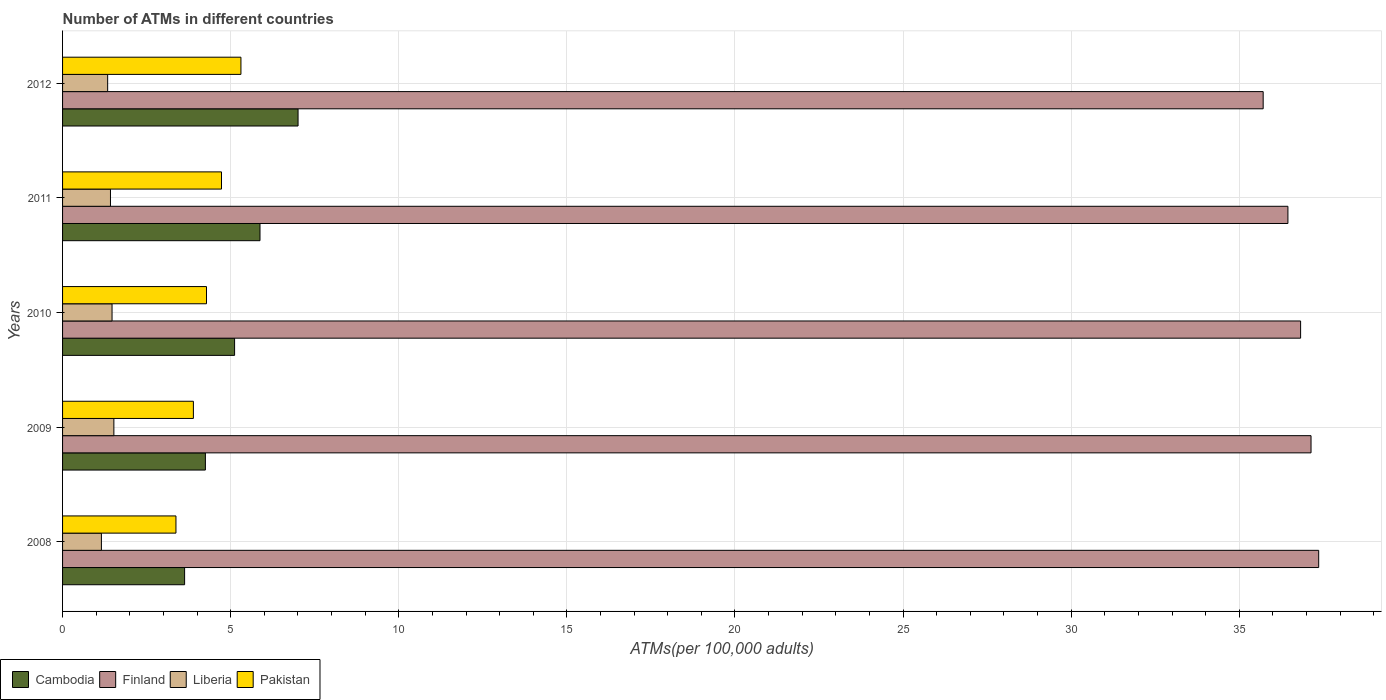Are the number of bars per tick equal to the number of legend labels?
Provide a short and direct response. Yes. How many bars are there on the 3rd tick from the bottom?
Your answer should be very brief. 4. In how many cases, is the number of bars for a given year not equal to the number of legend labels?
Your response must be concise. 0. What is the number of ATMs in Cambodia in 2008?
Your answer should be compact. 3.63. Across all years, what is the maximum number of ATMs in Liberia?
Ensure brevity in your answer.  1.53. Across all years, what is the minimum number of ATMs in Pakistan?
Make the answer very short. 3.37. In which year was the number of ATMs in Finland maximum?
Provide a short and direct response. 2008. In which year was the number of ATMs in Finland minimum?
Give a very brief answer. 2012. What is the total number of ATMs in Finland in the graph?
Your response must be concise. 183.48. What is the difference between the number of ATMs in Pakistan in 2011 and that in 2012?
Provide a short and direct response. -0.58. What is the difference between the number of ATMs in Liberia in 2010 and the number of ATMs in Cambodia in 2008?
Your answer should be very brief. -2.16. What is the average number of ATMs in Cambodia per year?
Provide a succinct answer. 5.17. In the year 2010, what is the difference between the number of ATMs in Liberia and number of ATMs in Finland?
Offer a very short reply. -35.35. What is the ratio of the number of ATMs in Pakistan in 2009 to that in 2011?
Offer a very short reply. 0.82. Is the number of ATMs in Liberia in 2008 less than that in 2009?
Ensure brevity in your answer.  Yes. What is the difference between the highest and the second highest number of ATMs in Finland?
Your answer should be compact. 0.23. What is the difference between the highest and the lowest number of ATMs in Liberia?
Provide a short and direct response. 0.37. In how many years, is the number of ATMs in Cambodia greater than the average number of ATMs in Cambodia taken over all years?
Offer a very short reply. 2. Is the sum of the number of ATMs in Pakistan in 2010 and 2011 greater than the maximum number of ATMs in Cambodia across all years?
Make the answer very short. Yes. What does the 4th bar from the top in 2011 represents?
Keep it short and to the point. Cambodia. Is it the case that in every year, the sum of the number of ATMs in Pakistan and number of ATMs in Liberia is greater than the number of ATMs in Finland?
Provide a short and direct response. No. How many bars are there?
Your answer should be compact. 20. Are all the bars in the graph horizontal?
Provide a short and direct response. Yes. How many years are there in the graph?
Give a very brief answer. 5. What is the difference between two consecutive major ticks on the X-axis?
Your response must be concise. 5. Are the values on the major ticks of X-axis written in scientific E-notation?
Keep it short and to the point. No. Does the graph contain any zero values?
Make the answer very short. No. How are the legend labels stacked?
Offer a very short reply. Horizontal. What is the title of the graph?
Provide a succinct answer. Number of ATMs in different countries. What is the label or title of the X-axis?
Your answer should be compact. ATMs(per 100,0 adults). What is the label or title of the Y-axis?
Offer a terse response. Years. What is the ATMs(per 100,000 adults) of Cambodia in 2008?
Provide a succinct answer. 3.63. What is the ATMs(per 100,000 adults) of Finland in 2008?
Your answer should be very brief. 37.36. What is the ATMs(per 100,000 adults) of Liberia in 2008?
Offer a very short reply. 1.16. What is the ATMs(per 100,000 adults) in Pakistan in 2008?
Offer a terse response. 3.37. What is the ATMs(per 100,000 adults) of Cambodia in 2009?
Your answer should be very brief. 4.25. What is the ATMs(per 100,000 adults) of Finland in 2009?
Keep it short and to the point. 37.13. What is the ATMs(per 100,000 adults) in Liberia in 2009?
Make the answer very short. 1.53. What is the ATMs(per 100,000 adults) in Pakistan in 2009?
Keep it short and to the point. 3.89. What is the ATMs(per 100,000 adults) of Cambodia in 2010?
Give a very brief answer. 5.12. What is the ATMs(per 100,000 adults) in Finland in 2010?
Offer a terse response. 36.82. What is the ATMs(per 100,000 adults) in Liberia in 2010?
Ensure brevity in your answer.  1.47. What is the ATMs(per 100,000 adults) in Pakistan in 2010?
Keep it short and to the point. 4.28. What is the ATMs(per 100,000 adults) in Cambodia in 2011?
Offer a very short reply. 5.87. What is the ATMs(per 100,000 adults) in Finland in 2011?
Provide a succinct answer. 36.45. What is the ATMs(per 100,000 adults) in Liberia in 2011?
Offer a terse response. 1.42. What is the ATMs(per 100,000 adults) of Pakistan in 2011?
Make the answer very short. 4.73. What is the ATMs(per 100,000 adults) of Cambodia in 2012?
Give a very brief answer. 7. What is the ATMs(per 100,000 adults) of Finland in 2012?
Your answer should be very brief. 35.71. What is the ATMs(per 100,000 adults) in Liberia in 2012?
Keep it short and to the point. 1.34. What is the ATMs(per 100,000 adults) of Pakistan in 2012?
Your answer should be compact. 5.31. Across all years, what is the maximum ATMs(per 100,000 adults) of Cambodia?
Offer a very short reply. 7. Across all years, what is the maximum ATMs(per 100,000 adults) in Finland?
Provide a short and direct response. 37.36. Across all years, what is the maximum ATMs(per 100,000 adults) of Liberia?
Offer a terse response. 1.53. Across all years, what is the maximum ATMs(per 100,000 adults) in Pakistan?
Make the answer very short. 5.31. Across all years, what is the minimum ATMs(per 100,000 adults) in Cambodia?
Offer a terse response. 3.63. Across all years, what is the minimum ATMs(per 100,000 adults) in Finland?
Your response must be concise. 35.71. Across all years, what is the minimum ATMs(per 100,000 adults) in Liberia?
Your answer should be very brief. 1.16. Across all years, what is the minimum ATMs(per 100,000 adults) in Pakistan?
Provide a succinct answer. 3.37. What is the total ATMs(per 100,000 adults) in Cambodia in the graph?
Your response must be concise. 25.87. What is the total ATMs(per 100,000 adults) of Finland in the graph?
Offer a terse response. 183.48. What is the total ATMs(per 100,000 adults) of Liberia in the graph?
Your response must be concise. 6.92. What is the total ATMs(per 100,000 adults) of Pakistan in the graph?
Provide a succinct answer. 21.58. What is the difference between the ATMs(per 100,000 adults) of Cambodia in 2008 and that in 2009?
Offer a terse response. -0.62. What is the difference between the ATMs(per 100,000 adults) of Finland in 2008 and that in 2009?
Make the answer very short. 0.23. What is the difference between the ATMs(per 100,000 adults) of Liberia in 2008 and that in 2009?
Your response must be concise. -0.37. What is the difference between the ATMs(per 100,000 adults) in Pakistan in 2008 and that in 2009?
Your response must be concise. -0.52. What is the difference between the ATMs(per 100,000 adults) in Cambodia in 2008 and that in 2010?
Your answer should be compact. -1.49. What is the difference between the ATMs(per 100,000 adults) of Finland in 2008 and that in 2010?
Your answer should be very brief. 0.54. What is the difference between the ATMs(per 100,000 adults) in Liberia in 2008 and that in 2010?
Offer a terse response. -0.32. What is the difference between the ATMs(per 100,000 adults) in Pakistan in 2008 and that in 2010?
Provide a succinct answer. -0.91. What is the difference between the ATMs(per 100,000 adults) of Cambodia in 2008 and that in 2011?
Your answer should be very brief. -2.24. What is the difference between the ATMs(per 100,000 adults) of Finland in 2008 and that in 2011?
Offer a very short reply. 0.92. What is the difference between the ATMs(per 100,000 adults) of Liberia in 2008 and that in 2011?
Ensure brevity in your answer.  -0.27. What is the difference between the ATMs(per 100,000 adults) in Pakistan in 2008 and that in 2011?
Your answer should be very brief. -1.35. What is the difference between the ATMs(per 100,000 adults) of Cambodia in 2008 and that in 2012?
Provide a succinct answer. -3.37. What is the difference between the ATMs(per 100,000 adults) in Finland in 2008 and that in 2012?
Your answer should be very brief. 1.65. What is the difference between the ATMs(per 100,000 adults) in Liberia in 2008 and that in 2012?
Make the answer very short. -0.19. What is the difference between the ATMs(per 100,000 adults) of Pakistan in 2008 and that in 2012?
Offer a terse response. -1.93. What is the difference between the ATMs(per 100,000 adults) in Cambodia in 2009 and that in 2010?
Offer a very short reply. -0.87. What is the difference between the ATMs(per 100,000 adults) in Finland in 2009 and that in 2010?
Keep it short and to the point. 0.31. What is the difference between the ATMs(per 100,000 adults) of Liberia in 2009 and that in 2010?
Make the answer very short. 0.05. What is the difference between the ATMs(per 100,000 adults) of Pakistan in 2009 and that in 2010?
Keep it short and to the point. -0.39. What is the difference between the ATMs(per 100,000 adults) of Cambodia in 2009 and that in 2011?
Provide a succinct answer. -1.62. What is the difference between the ATMs(per 100,000 adults) in Finland in 2009 and that in 2011?
Give a very brief answer. 0.69. What is the difference between the ATMs(per 100,000 adults) in Liberia in 2009 and that in 2011?
Offer a terse response. 0.1. What is the difference between the ATMs(per 100,000 adults) of Pakistan in 2009 and that in 2011?
Keep it short and to the point. -0.84. What is the difference between the ATMs(per 100,000 adults) of Cambodia in 2009 and that in 2012?
Provide a succinct answer. -2.76. What is the difference between the ATMs(per 100,000 adults) of Finland in 2009 and that in 2012?
Your answer should be compact. 1.42. What is the difference between the ATMs(per 100,000 adults) of Liberia in 2009 and that in 2012?
Your answer should be very brief. 0.19. What is the difference between the ATMs(per 100,000 adults) of Pakistan in 2009 and that in 2012?
Offer a very short reply. -1.41. What is the difference between the ATMs(per 100,000 adults) in Cambodia in 2010 and that in 2011?
Keep it short and to the point. -0.76. What is the difference between the ATMs(per 100,000 adults) in Finland in 2010 and that in 2011?
Make the answer very short. 0.38. What is the difference between the ATMs(per 100,000 adults) of Liberia in 2010 and that in 2011?
Ensure brevity in your answer.  0.05. What is the difference between the ATMs(per 100,000 adults) of Pakistan in 2010 and that in 2011?
Keep it short and to the point. -0.45. What is the difference between the ATMs(per 100,000 adults) of Cambodia in 2010 and that in 2012?
Offer a terse response. -1.89. What is the difference between the ATMs(per 100,000 adults) of Finland in 2010 and that in 2012?
Give a very brief answer. 1.11. What is the difference between the ATMs(per 100,000 adults) of Liberia in 2010 and that in 2012?
Offer a terse response. 0.13. What is the difference between the ATMs(per 100,000 adults) of Pakistan in 2010 and that in 2012?
Make the answer very short. -1.02. What is the difference between the ATMs(per 100,000 adults) of Cambodia in 2011 and that in 2012?
Provide a short and direct response. -1.13. What is the difference between the ATMs(per 100,000 adults) of Finland in 2011 and that in 2012?
Make the answer very short. 0.74. What is the difference between the ATMs(per 100,000 adults) of Liberia in 2011 and that in 2012?
Keep it short and to the point. 0.08. What is the difference between the ATMs(per 100,000 adults) in Pakistan in 2011 and that in 2012?
Provide a short and direct response. -0.58. What is the difference between the ATMs(per 100,000 adults) in Cambodia in 2008 and the ATMs(per 100,000 adults) in Finland in 2009?
Your response must be concise. -33.5. What is the difference between the ATMs(per 100,000 adults) of Cambodia in 2008 and the ATMs(per 100,000 adults) of Liberia in 2009?
Your response must be concise. 2.1. What is the difference between the ATMs(per 100,000 adults) in Cambodia in 2008 and the ATMs(per 100,000 adults) in Pakistan in 2009?
Provide a short and direct response. -0.26. What is the difference between the ATMs(per 100,000 adults) in Finland in 2008 and the ATMs(per 100,000 adults) in Liberia in 2009?
Ensure brevity in your answer.  35.84. What is the difference between the ATMs(per 100,000 adults) of Finland in 2008 and the ATMs(per 100,000 adults) of Pakistan in 2009?
Ensure brevity in your answer.  33.47. What is the difference between the ATMs(per 100,000 adults) in Liberia in 2008 and the ATMs(per 100,000 adults) in Pakistan in 2009?
Your response must be concise. -2.74. What is the difference between the ATMs(per 100,000 adults) of Cambodia in 2008 and the ATMs(per 100,000 adults) of Finland in 2010?
Your answer should be very brief. -33.19. What is the difference between the ATMs(per 100,000 adults) in Cambodia in 2008 and the ATMs(per 100,000 adults) in Liberia in 2010?
Make the answer very short. 2.16. What is the difference between the ATMs(per 100,000 adults) in Cambodia in 2008 and the ATMs(per 100,000 adults) in Pakistan in 2010?
Provide a succinct answer. -0.65. What is the difference between the ATMs(per 100,000 adults) of Finland in 2008 and the ATMs(per 100,000 adults) of Liberia in 2010?
Provide a succinct answer. 35.89. What is the difference between the ATMs(per 100,000 adults) in Finland in 2008 and the ATMs(per 100,000 adults) in Pakistan in 2010?
Offer a terse response. 33.08. What is the difference between the ATMs(per 100,000 adults) in Liberia in 2008 and the ATMs(per 100,000 adults) in Pakistan in 2010?
Your answer should be compact. -3.13. What is the difference between the ATMs(per 100,000 adults) in Cambodia in 2008 and the ATMs(per 100,000 adults) in Finland in 2011?
Keep it short and to the point. -32.82. What is the difference between the ATMs(per 100,000 adults) in Cambodia in 2008 and the ATMs(per 100,000 adults) in Liberia in 2011?
Your answer should be very brief. 2.21. What is the difference between the ATMs(per 100,000 adults) in Cambodia in 2008 and the ATMs(per 100,000 adults) in Pakistan in 2011?
Keep it short and to the point. -1.1. What is the difference between the ATMs(per 100,000 adults) of Finland in 2008 and the ATMs(per 100,000 adults) of Liberia in 2011?
Keep it short and to the point. 35.94. What is the difference between the ATMs(per 100,000 adults) in Finland in 2008 and the ATMs(per 100,000 adults) in Pakistan in 2011?
Make the answer very short. 32.63. What is the difference between the ATMs(per 100,000 adults) in Liberia in 2008 and the ATMs(per 100,000 adults) in Pakistan in 2011?
Give a very brief answer. -3.57. What is the difference between the ATMs(per 100,000 adults) in Cambodia in 2008 and the ATMs(per 100,000 adults) in Finland in 2012?
Offer a terse response. -32.08. What is the difference between the ATMs(per 100,000 adults) of Cambodia in 2008 and the ATMs(per 100,000 adults) of Liberia in 2012?
Make the answer very short. 2.29. What is the difference between the ATMs(per 100,000 adults) in Cambodia in 2008 and the ATMs(per 100,000 adults) in Pakistan in 2012?
Provide a succinct answer. -1.68. What is the difference between the ATMs(per 100,000 adults) in Finland in 2008 and the ATMs(per 100,000 adults) in Liberia in 2012?
Offer a terse response. 36.02. What is the difference between the ATMs(per 100,000 adults) in Finland in 2008 and the ATMs(per 100,000 adults) in Pakistan in 2012?
Make the answer very short. 32.06. What is the difference between the ATMs(per 100,000 adults) in Liberia in 2008 and the ATMs(per 100,000 adults) in Pakistan in 2012?
Your response must be concise. -4.15. What is the difference between the ATMs(per 100,000 adults) in Cambodia in 2009 and the ATMs(per 100,000 adults) in Finland in 2010?
Your answer should be compact. -32.58. What is the difference between the ATMs(per 100,000 adults) in Cambodia in 2009 and the ATMs(per 100,000 adults) in Liberia in 2010?
Ensure brevity in your answer.  2.78. What is the difference between the ATMs(per 100,000 adults) of Cambodia in 2009 and the ATMs(per 100,000 adults) of Pakistan in 2010?
Offer a terse response. -0.03. What is the difference between the ATMs(per 100,000 adults) of Finland in 2009 and the ATMs(per 100,000 adults) of Liberia in 2010?
Your answer should be compact. 35.66. What is the difference between the ATMs(per 100,000 adults) of Finland in 2009 and the ATMs(per 100,000 adults) of Pakistan in 2010?
Provide a short and direct response. 32.85. What is the difference between the ATMs(per 100,000 adults) of Liberia in 2009 and the ATMs(per 100,000 adults) of Pakistan in 2010?
Offer a very short reply. -2.76. What is the difference between the ATMs(per 100,000 adults) in Cambodia in 2009 and the ATMs(per 100,000 adults) in Finland in 2011?
Give a very brief answer. -32.2. What is the difference between the ATMs(per 100,000 adults) in Cambodia in 2009 and the ATMs(per 100,000 adults) in Liberia in 2011?
Keep it short and to the point. 2.82. What is the difference between the ATMs(per 100,000 adults) in Cambodia in 2009 and the ATMs(per 100,000 adults) in Pakistan in 2011?
Keep it short and to the point. -0.48. What is the difference between the ATMs(per 100,000 adults) of Finland in 2009 and the ATMs(per 100,000 adults) of Liberia in 2011?
Offer a very short reply. 35.71. What is the difference between the ATMs(per 100,000 adults) in Finland in 2009 and the ATMs(per 100,000 adults) in Pakistan in 2011?
Your answer should be very brief. 32.41. What is the difference between the ATMs(per 100,000 adults) in Liberia in 2009 and the ATMs(per 100,000 adults) in Pakistan in 2011?
Your answer should be very brief. -3.2. What is the difference between the ATMs(per 100,000 adults) of Cambodia in 2009 and the ATMs(per 100,000 adults) of Finland in 2012?
Keep it short and to the point. -31.46. What is the difference between the ATMs(per 100,000 adults) in Cambodia in 2009 and the ATMs(per 100,000 adults) in Liberia in 2012?
Provide a succinct answer. 2.91. What is the difference between the ATMs(per 100,000 adults) of Cambodia in 2009 and the ATMs(per 100,000 adults) of Pakistan in 2012?
Offer a very short reply. -1.06. What is the difference between the ATMs(per 100,000 adults) of Finland in 2009 and the ATMs(per 100,000 adults) of Liberia in 2012?
Give a very brief answer. 35.79. What is the difference between the ATMs(per 100,000 adults) in Finland in 2009 and the ATMs(per 100,000 adults) in Pakistan in 2012?
Provide a succinct answer. 31.83. What is the difference between the ATMs(per 100,000 adults) in Liberia in 2009 and the ATMs(per 100,000 adults) in Pakistan in 2012?
Make the answer very short. -3.78. What is the difference between the ATMs(per 100,000 adults) in Cambodia in 2010 and the ATMs(per 100,000 adults) in Finland in 2011?
Provide a succinct answer. -31.33. What is the difference between the ATMs(per 100,000 adults) of Cambodia in 2010 and the ATMs(per 100,000 adults) of Liberia in 2011?
Make the answer very short. 3.69. What is the difference between the ATMs(per 100,000 adults) in Cambodia in 2010 and the ATMs(per 100,000 adults) in Pakistan in 2011?
Offer a very short reply. 0.39. What is the difference between the ATMs(per 100,000 adults) of Finland in 2010 and the ATMs(per 100,000 adults) of Liberia in 2011?
Ensure brevity in your answer.  35.4. What is the difference between the ATMs(per 100,000 adults) in Finland in 2010 and the ATMs(per 100,000 adults) in Pakistan in 2011?
Give a very brief answer. 32.1. What is the difference between the ATMs(per 100,000 adults) in Liberia in 2010 and the ATMs(per 100,000 adults) in Pakistan in 2011?
Your answer should be very brief. -3.26. What is the difference between the ATMs(per 100,000 adults) in Cambodia in 2010 and the ATMs(per 100,000 adults) in Finland in 2012?
Your response must be concise. -30.59. What is the difference between the ATMs(per 100,000 adults) in Cambodia in 2010 and the ATMs(per 100,000 adults) in Liberia in 2012?
Make the answer very short. 3.78. What is the difference between the ATMs(per 100,000 adults) in Cambodia in 2010 and the ATMs(per 100,000 adults) in Pakistan in 2012?
Keep it short and to the point. -0.19. What is the difference between the ATMs(per 100,000 adults) in Finland in 2010 and the ATMs(per 100,000 adults) in Liberia in 2012?
Keep it short and to the point. 35.48. What is the difference between the ATMs(per 100,000 adults) in Finland in 2010 and the ATMs(per 100,000 adults) in Pakistan in 2012?
Offer a terse response. 31.52. What is the difference between the ATMs(per 100,000 adults) in Liberia in 2010 and the ATMs(per 100,000 adults) in Pakistan in 2012?
Ensure brevity in your answer.  -3.83. What is the difference between the ATMs(per 100,000 adults) of Cambodia in 2011 and the ATMs(per 100,000 adults) of Finland in 2012?
Offer a terse response. -29.84. What is the difference between the ATMs(per 100,000 adults) of Cambodia in 2011 and the ATMs(per 100,000 adults) of Liberia in 2012?
Offer a terse response. 4.53. What is the difference between the ATMs(per 100,000 adults) of Cambodia in 2011 and the ATMs(per 100,000 adults) of Pakistan in 2012?
Keep it short and to the point. 0.57. What is the difference between the ATMs(per 100,000 adults) of Finland in 2011 and the ATMs(per 100,000 adults) of Liberia in 2012?
Your answer should be very brief. 35.11. What is the difference between the ATMs(per 100,000 adults) in Finland in 2011 and the ATMs(per 100,000 adults) in Pakistan in 2012?
Provide a short and direct response. 31.14. What is the difference between the ATMs(per 100,000 adults) of Liberia in 2011 and the ATMs(per 100,000 adults) of Pakistan in 2012?
Your answer should be very brief. -3.88. What is the average ATMs(per 100,000 adults) of Cambodia per year?
Keep it short and to the point. 5.17. What is the average ATMs(per 100,000 adults) of Finland per year?
Make the answer very short. 36.7. What is the average ATMs(per 100,000 adults) in Liberia per year?
Make the answer very short. 1.38. What is the average ATMs(per 100,000 adults) of Pakistan per year?
Your answer should be compact. 4.32. In the year 2008, what is the difference between the ATMs(per 100,000 adults) in Cambodia and ATMs(per 100,000 adults) in Finland?
Give a very brief answer. -33.73. In the year 2008, what is the difference between the ATMs(per 100,000 adults) in Cambodia and ATMs(per 100,000 adults) in Liberia?
Make the answer very short. 2.47. In the year 2008, what is the difference between the ATMs(per 100,000 adults) of Cambodia and ATMs(per 100,000 adults) of Pakistan?
Your answer should be compact. 0.26. In the year 2008, what is the difference between the ATMs(per 100,000 adults) in Finland and ATMs(per 100,000 adults) in Liberia?
Keep it short and to the point. 36.21. In the year 2008, what is the difference between the ATMs(per 100,000 adults) in Finland and ATMs(per 100,000 adults) in Pakistan?
Provide a short and direct response. 33.99. In the year 2008, what is the difference between the ATMs(per 100,000 adults) in Liberia and ATMs(per 100,000 adults) in Pakistan?
Provide a succinct answer. -2.22. In the year 2009, what is the difference between the ATMs(per 100,000 adults) in Cambodia and ATMs(per 100,000 adults) in Finland?
Provide a short and direct response. -32.89. In the year 2009, what is the difference between the ATMs(per 100,000 adults) of Cambodia and ATMs(per 100,000 adults) of Liberia?
Make the answer very short. 2.72. In the year 2009, what is the difference between the ATMs(per 100,000 adults) in Cambodia and ATMs(per 100,000 adults) in Pakistan?
Ensure brevity in your answer.  0.36. In the year 2009, what is the difference between the ATMs(per 100,000 adults) of Finland and ATMs(per 100,000 adults) of Liberia?
Give a very brief answer. 35.61. In the year 2009, what is the difference between the ATMs(per 100,000 adults) in Finland and ATMs(per 100,000 adults) in Pakistan?
Your response must be concise. 33.24. In the year 2009, what is the difference between the ATMs(per 100,000 adults) of Liberia and ATMs(per 100,000 adults) of Pakistan?
Your answer should be compact. -2.37. In the year 2010, what is the difference between the ATMs(per 100,000 adults) in Cambodia and ATMs(per 100,000 adults) in Finland?
Make the answer very short. -31.71. In the year 2010, what is the difference between the ATMs(per 100,000 adults) of Cambodia and ATMs(per 100,000 adults) of Liberia?
Your answer should be very brief. 3.64. In the year 2010, what is the difference between the ATMs(per 100,000 adults) in Cambodia and ATMs(per 100,000 adults) in Pakistan?
Your answer should be compact. 0.84. In the year 2010, what is the difference between the ATMs(per 100,000 adults) in Finland and ATMs(per 100,000 adults) in Liberia?
Provide a short and direct response. 35.35. In the year 2010, what is the difference between the ATMs(per 100,000 adults) of Finland and ATMs(per 100,000 adults) of Pakistan?
Give a very brief answer. 32.54. In the year 2010, what is the difference between the ATMs(per 100,000 adults) of Liberia and ATMs(per 100,000 adults) of Pakistan?
Offer a terse response. -2.81. In the year 2011, what is the difference between the ATMs(per 100,000 adults) in Cambodia and ATMs(per 100,000 adults) in Finland?
Keep it short and to the point. -30.57. In the year 2011, what is the difference between the ATMs(per 100,000 adults) of Cambodia and ATMs(per 100,000 adults) of Liberia?
Your answer should be very brief. 4.45. In the year 2011, what is the difference between the ATMs(per 100,000 adults) in Cambodia and ATMs(per 100,000 adults) in Pakistan?
Your answer should be very brief. 1.15. In the year 2011, what is the difference between the ATMs(per 100,000 adults) in Finland and ATMs(per 100,000 adults) in Liberia?
Offer a very short reply. 35.02. In the year 2011, what is the difference between the ATMs(per 100,000 adults) in Finland and ATMs(per 100,000 adults) in Pakistan?
Make the answer very short. 31.72. In the year 2011, what is the difference between the ATMs(per 100,000 adults) of Liberia and ATMs(per 100,000 adults) of Pakistan?
Your answer should be compact. -3.3. In the year 2012, what is the difference between the ATMs(per 100,000 adults) in Cambodia and ATMs(per 100,000 adults) in Finland?
Offer a very short reply. -28.71. In the year 2012, what is the difference between the ATMs(per 100,000 adults) in Cambodia and ATMs(per 100,000 adults) in Liberia?
Keep it short and to the point. 5.66. In the year 2012, what is the difference between the ATMs(per 100,000 adults) in Cambodia and ATMs(per 100,000 adults) in Pakistan?
Your answer should be compact. 1.7. In the year 2012, what is the difference between the ATMs(per 100,000 adults) in Finland and ATMs(per 100,000 adults) in Liberia?
Ensure brevity in your answer.  34.37. In the year 2012, what is the difference between the ATMs(per 100,000 adults) in Finland and ATMs(per 100,000 adults) in Pakistan?
Your answer should be very brief. 30.41. In the year 2012, what is the difference between the ATMs(per 100,000 adults) of Liberia and ATMs(per 100,000 adults) of Pakistan?
Make the answer very short. -3.96. What is the ratio of the ATMs(per 100,000 adults) of Cambodia in 2008 to that in 2009?
Provide a short and direct response. 0.85. What is the ratio of the ATMs(per 100,000 adults) of Liberia in 2008 to that in 2009?
Provide a short and direct response. 0.76. What is the ratio of the ATMs(per 100,000 adults) in Pakistan in 2008 to that in 2009?
Provide a succinct answer. 0.87. What is the ratio of the ATMs(per 100,000 adults) of Cambodia in 2008 to that in 2010?
Ensure brevity in your answer.  0.71. What is the ratio of the ATMs(per 100,000 adults) in Finland in 2008 to that in 2010?
Your answer should be very brief. 1.01. What is the ratio of the ATMs(per 100,000 adults) of Liberia in 2008 to that in 2010?
Provide a short and direct response. 0.79. What is the ratio of the ATMs(per 100,000 adults) of Pakistan in 2008 to that in 2010?
Provide a short and direct response. 0.79. What is the ratio of the ATMs(per 100,000 adults) in Cambodia in 2008 to that in 2011?
Your response must be concise. 0.62. What is the ratio of the ATMs(per 100,000 adults) in Finland in 2008 to that in 2011?
Provide a short and direct response. 1.03. What is the ratio of the ATMs(per 100,000 adults) of Liberia in 2008 to that in 2011?
Keep it short and to the point. 0.81. What is the ratio of the ATMs(per 100,000 adults) in Pakistan in 2008 to that in 2011?
Your response must be concise. 0.71. What is the ratio of the ATMs(per 100,000 adults) of Cambodia in 2008 to that in 2012?
Provide a succinct answer. 0.52. What is the ratio of the ATMs(per 100,000 adults) in Finland in 2008 to that in 2012?
Give a very brief answer. 1.05. What is the ratio of the ATMs(per 100,000 adults) in Liberia in 2008 to that in 2012?
Offer a very short reply. 0.86. What is the ratio of the ATMs(per 100,000 adults) of Pakistan in 2008 to that in 2012?
Your response must be concise. 0.64. What is the ratio of the ATMs(per 100,000 adults) of Cambodia in 2009 to that in 2010?
Provide a succinct answer. 0.83. What is the ratio of the ATMs(per 100,000 adults) of Finland in 2009 to that in 2010?
Your answer should be compact. 1.01. What is the ratio of the ATMs(per 100,000 adults) of Pakistan in 2009 to that in 2010?
Your answer should be very brief. 0.91. What is the ratio of the ATMs(per 100,000 adults) in Cambodia in 2009 to that in 2011?
Keep it short and to the point. 0.72. What is the ratio of the ATMs(per 100,000 adults) of Finland in 2009 to that in 2011?
Your answer should be compact. 1.02. What is the ratio of the ATMs(per 100,000 adults) of Liberia in 2009 to that in 2011?
Offer a terse response. 1.07. What is the ratio of the ATMs(per 100,000 adults) in Pakistan in 2009 to that in 2011?
Ensure brevity in your answer.  0.82. What is the ratio of the ATMs(per 100,000 adults) in Cambodia in 2009 to that in 2012?
Provide a succinct answer. 0.61. What is the ratio of the ATMs(per 100,000 adults) of Finland in 2009 to that in 2012?
Provide a succinct answer. 1.04. What is the ratio of the ATMs(per 100,000 adults) of Liberia in 2009 to that in 2012?
Ensure brevity in your answer.  1.14. What is the ratio of the ATMs(per 100,000 adults) of Pakistan in 2009 to that in 2012?
Keep it short and to the point. 0.73. What is the ratio of the ATMs(per 100,000 adults) of Cambodia in 2010 to that in 2011?
Your response must be concise. 0.87. What is the ratio of the ATMs(per 100,000 adults) in Finland in 2010 to that in 2011?
Your answer should be compact. 1.01. What is the ratio of the ATMs(per 100,000 adults) of Liberia in 2010 to that in 2011?
Provide a succinct answer. 1.03. What is the ratio of the ATMs(per 100,000 adults) in Pakistan in 2010 to that in 2011?
Offer a very short reply. 0.91. What is the ratio of the ATMs(per 100,000 adults) of Cambodia in 2010 to that in 2012?
Your answer should be compact. 0.73. What is the ratio of the ATMs(per 100,000 adults) of Finland in 2010 to that in 2012?
Offer a very short reply. 1.03. What is the ratio of the ATMs(per 100,000 adults) in Liberia in 2010 to that in 2012?
Make the answer very short. 1.1. What is the ratio of the ATMs(per 100,000 adults) of Pakistan in 2010 to that in 2012?
Offer a terse response. 0.81. What is the ratio of the ATMs(per 100,000 adults) in Cambodia in 2011 to that in 2012?
Provide a short and direct response. 0.84. What is the ratio of the ATMs(per 100,000 adults) in Finland in 2011 to that in 2012?
Keep it short and to the point. 1.02. What is the ratio of the ATMs(per 100,000 adults) in Liberia in 2011 to that in 2012?
Make the answer very short. 1.06. What is the ratio of the ATMs(per 100,000 adults) of Pakistan in 2011 to that in 2012?
Your response must be concise. 0.89. What is the difference between the highest and the second highest ATMs(per 100,000 adults) in Cambodia?
Provide a succinct answer. 1.13. What is the difference between the highest and the second highest ATMs(per 100,000 adults) in Finland?
Ensure brevity in your answer.  0.23. What is the difference between the highest and the second highest ATMs(per 100,000 adults) of Liberia?
Keep it short and to the point. 0.05. What is the difference between the highest and the second highest ATMs(per 100,000 adults) of Pakistan?
Offer a very short reply. 0.58. What is the difference between the highest and the lowest ATMs(per 100,000 adults) of Cambodia?
Provide a short and direct response. 3.37. What is the difference between the highest and the lowest ATMs(per 100,000 adults) in Finland?
Provide a succinct answer. 1.65. What is the difference between the highest and the lowest ATMs(per 100,000 adults) in Liberia?
Provide a short and direct response. 0.37. What is the difference between the highest and the lowest ATMs(per 100,000 adults) of Pakistan?
Offer a very short reply. 1.93. 